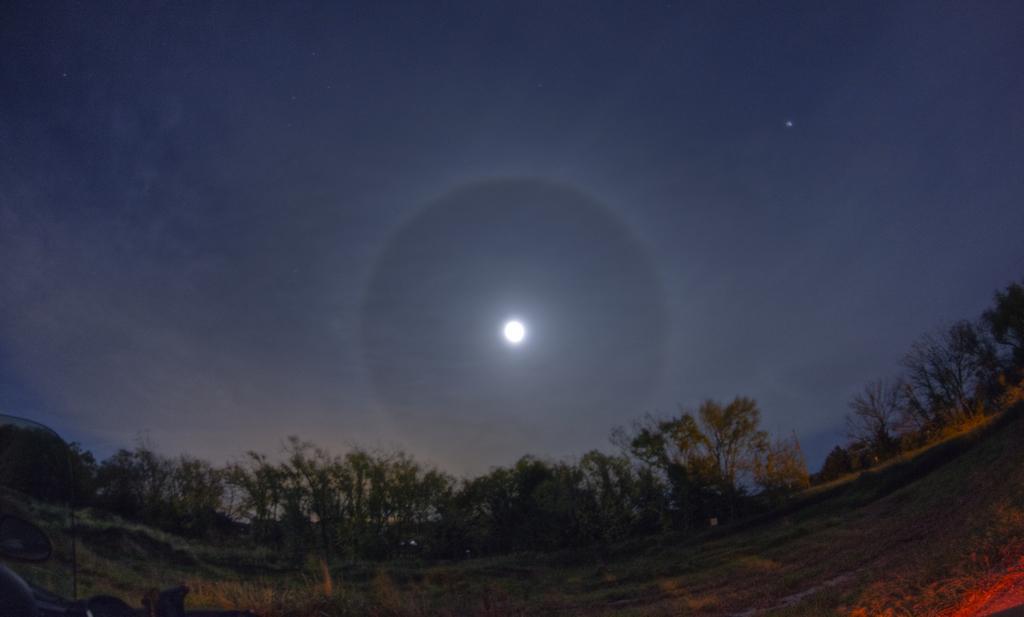Could you give a brief overview of what you see in this image? In this image there is a land, in the background there are trees and the sky, in that sky there is a moon. 